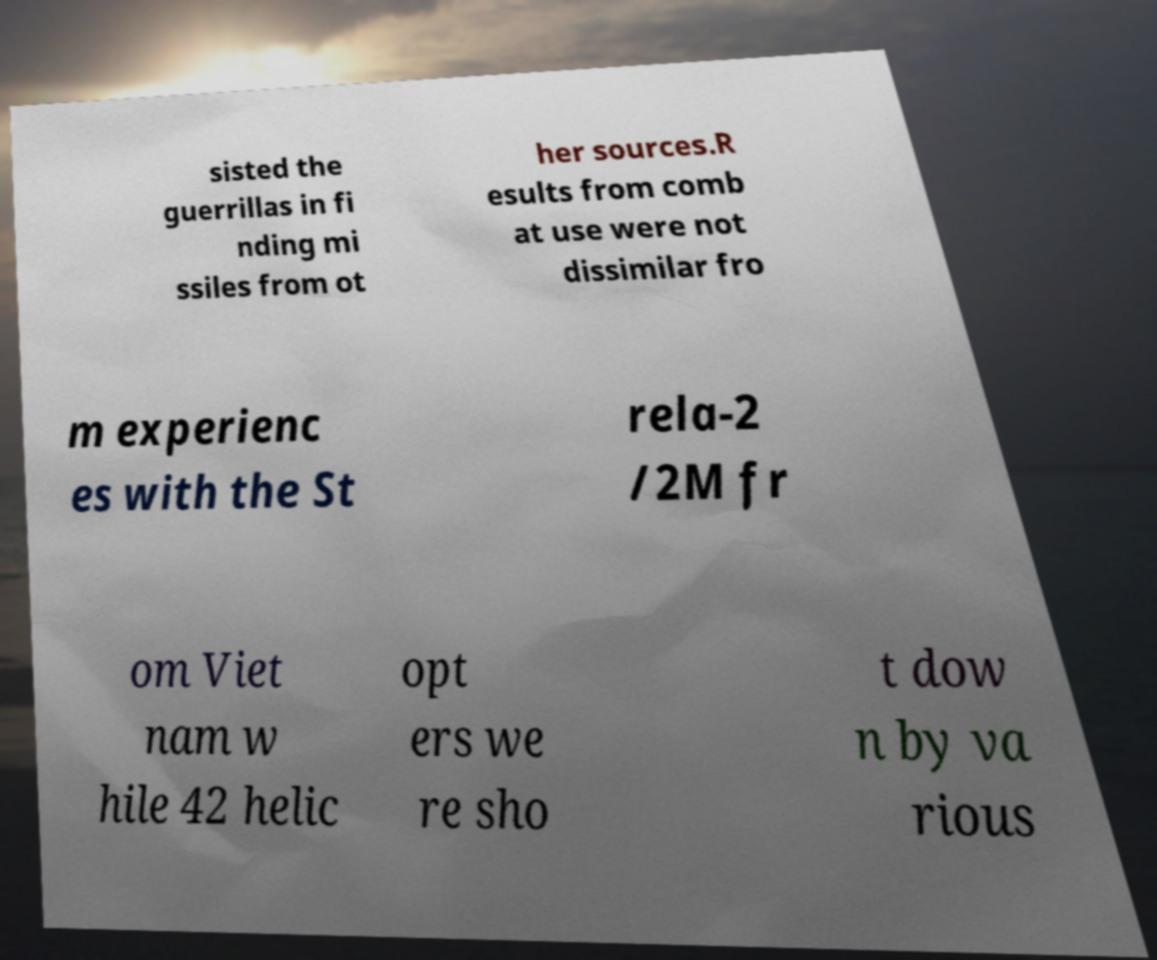Please identify and transcribe the text found in this image. sisted the guerrillas in fi nding mi ssiles from ot her sources.R esults from comb at use were not dissimilar fro m experienc es with the St rela-2 /2M fr om Viet nam w hile 42 helic opt ers we re sho t dow n by va rious 